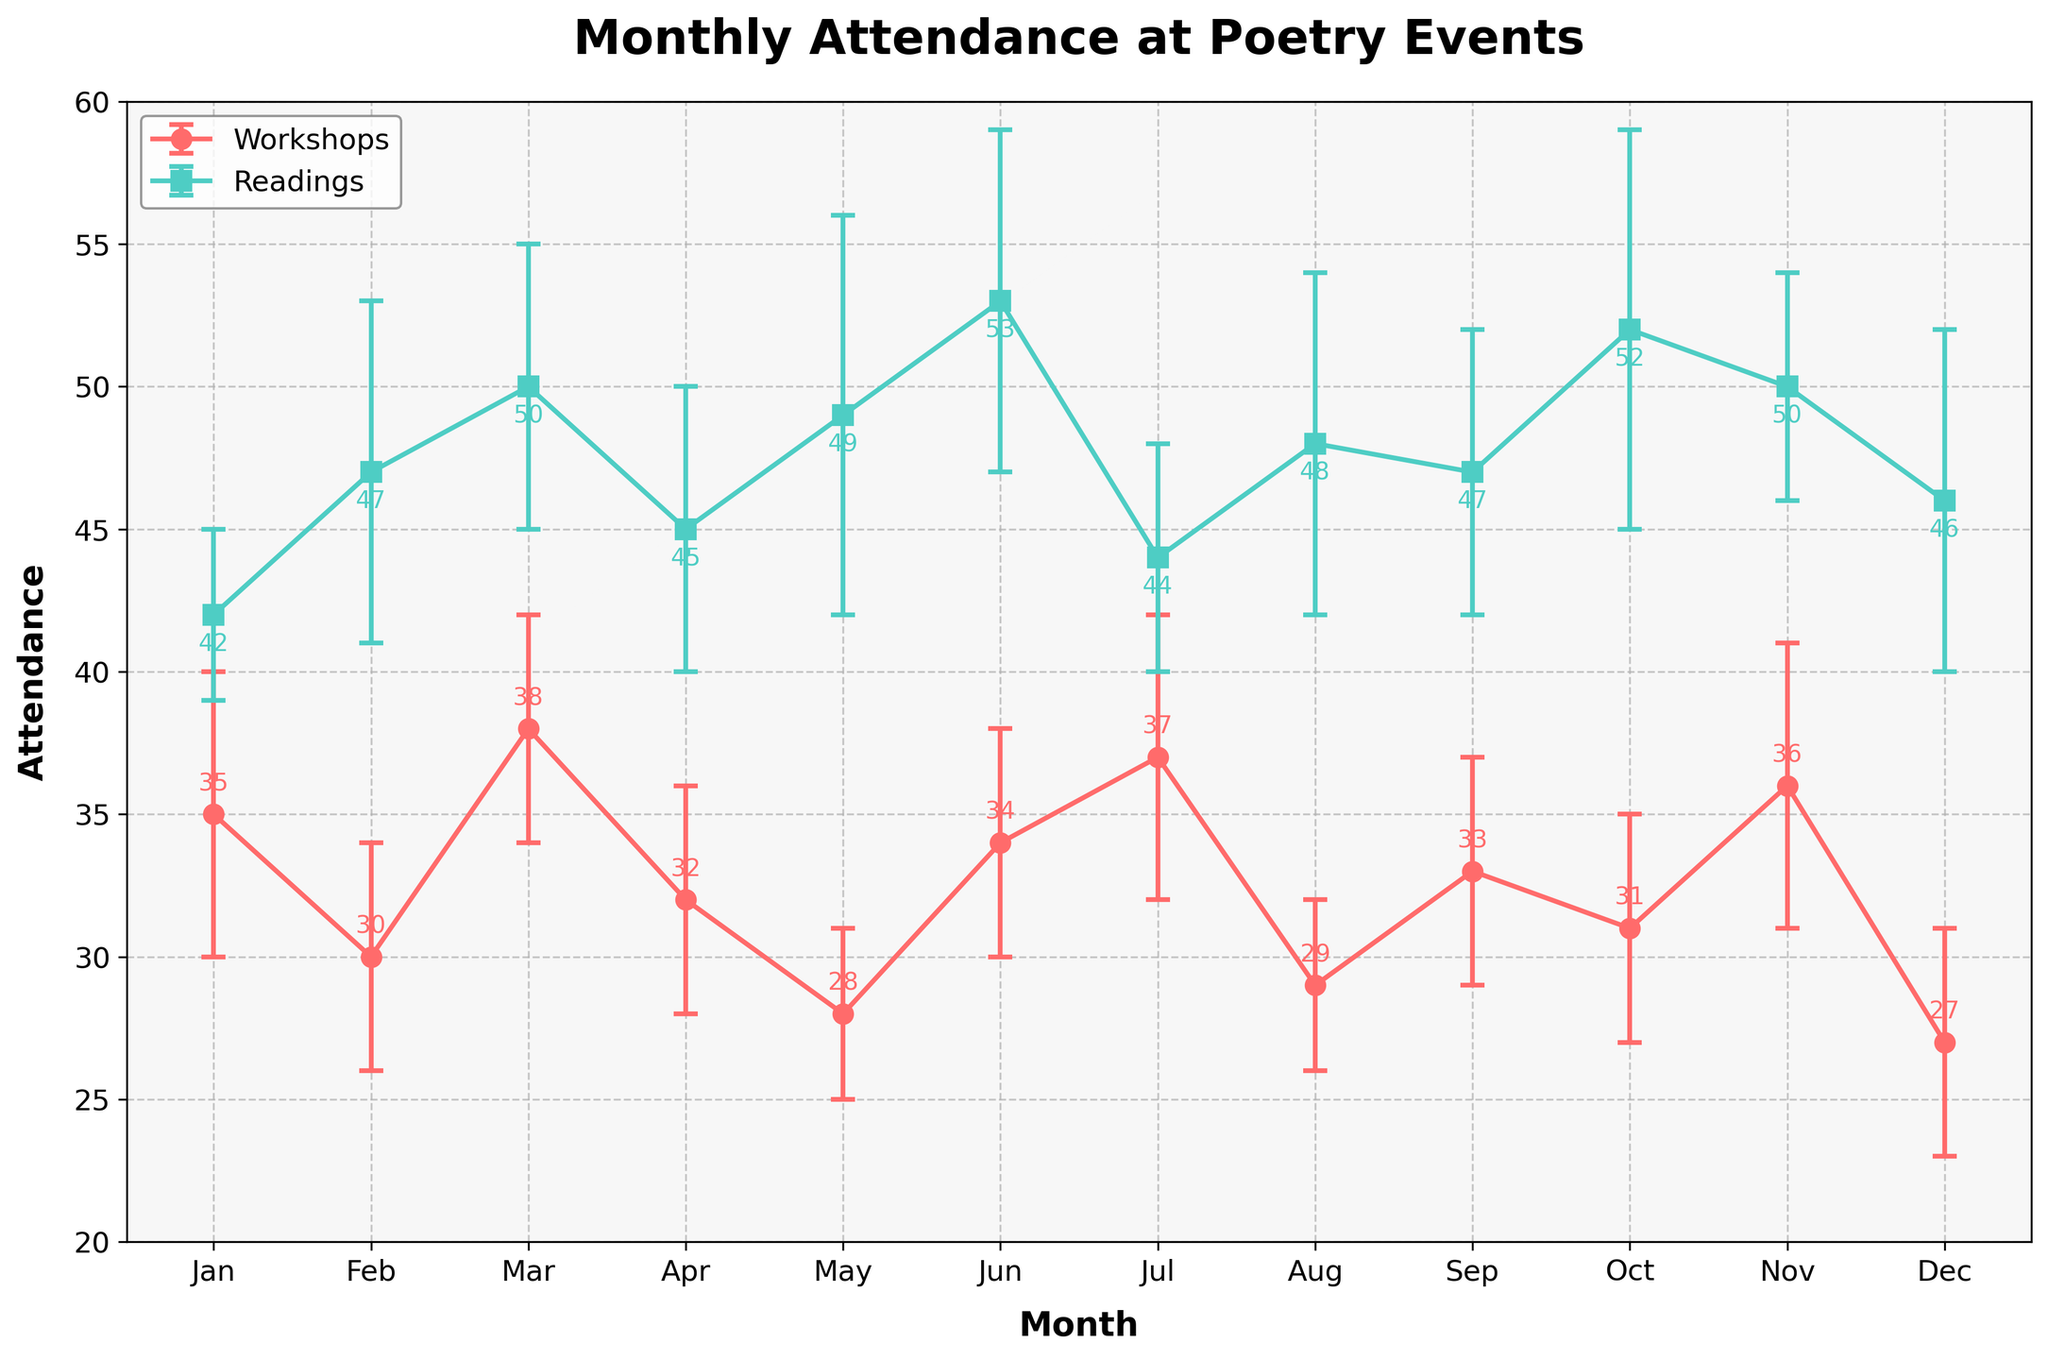What is the title of the plot? The title is the text that appears at the top of the plot. In this case, the title is clearly written as 'Monthly Attendance at Poetry Events'.
Answer: Monthly Attendance at Poetry Events What color are the lines representing workshop attendance? The color of the lines for workshop attendance is distinct from the readings. According to the legend, the workshops are represented by the color that resembles red or pink.
Answer: Red/Pink Which month had the highest attendance at readings? By looking at the line representing readings and identifying the peak point, we see that June has the highest attendance.
Answer: June What is the attendance for workshops in both January and November? Refer to the data points for workshops in January and November. The plot shows values of 35 for January and 36 for November.
Answer: January: 35, November: 36 What is the difference in attendance between workshops and readings for the month of August? Locate the data points for both workshops and readings in August. The workshop has an attendance of 29, and the reading has an attendance of 48. The difference is 48 - 29 = 19.
Answer: 19 Which event type has more attendance on average, workshops or readings? Compute the average attendance for each event type. Sum the attendance for each type and divide by the number of months (12). Workshops: (35+30+38+32+28+34+37+29+33+31+36+27)/12 = 32, Readings: (42+47+50+45+49+53+44+48+47+52+50+46)/12 ≈ 48.
Answer: Readings Is there any month where the attendance for workshops is higher than readings? Compare workshop and reading attendance for each month. No month has higher workshop attendance compared to readings.
Answer: No What are the uncertainties in attendance for workshops in March and readings in October? Check the error bars for workshops in March and readings in October. Workshops in March have an uncertainty of 4, readings in October have an uncertainty of 7.
Answer: March: 4, October: 7 Which month has the lowest attendance for workshops? Identify the lowest point on the workshops line. December shows the lowest attendance value of 27.
Answer: December 